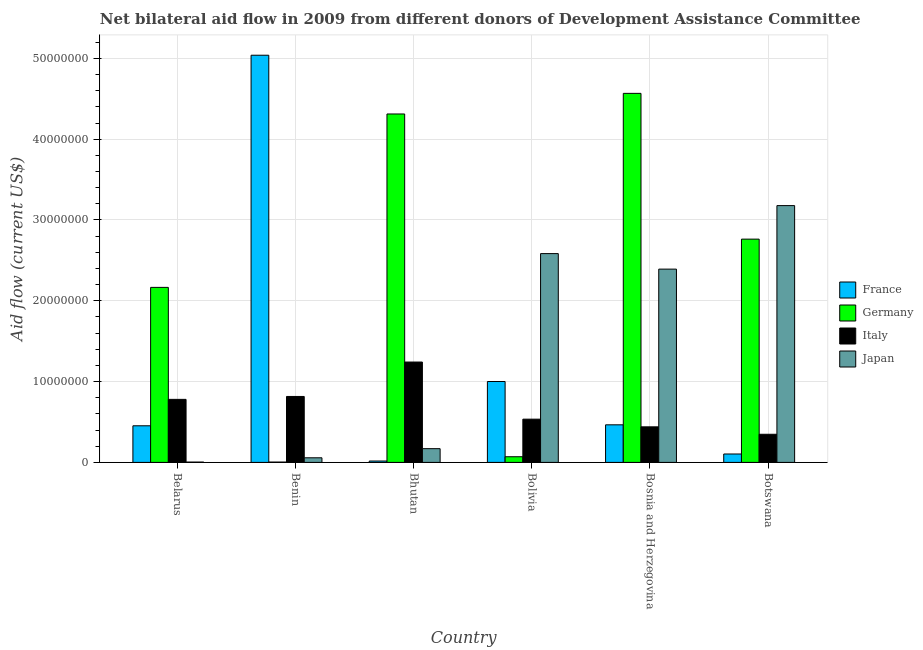Are the number of bars on each tick of the X-axis equal?
Keep it short and to the point. Yes. How many bars are there on the 4th tick from the right?
Offer a very short reply. 4. What is the label of the 6th group of bars from the left?
Offer a very short reply. Botswana. In how many cases, is the number of bars for a given country not equal to the number of legend labels?
Your response must be concise. 0. What is the amount of aid given by japan in Benin?
Give a very brief answer. 5.70e+05. Across all countries, what is the maximum amount of aid given by germany?
Offer a terse response. 4.57e+07. Across all countries, what is the minimum amount of aid given by italy?
Your answer should be very brief. 3.48e+06. In which country was the amount of aid given by italy maximum?
Your answer should be compact. Bhutan. In which country was the amount of aid given by germany minimum?
Your answer should be compact. Benin. What is the total amount of aid given by japan in the graph?
Your response must be concise. 8.38e+07. What is the difference between the amount of aid given by italy in Belarus and that in Bolivia?
Give a very brief answer. 2.45e+06. What is the difference between the amount of aid given by japan in Botswana and the amount of aid given by france in Bhutan?
Your response must be concise. 3.16e+07. What is the average amount of aid given by italy per country?
Offer a terse response. 6.94e+06. What is the difference between the amount of aid given by france and amount of aid given by germany in Bhutan?
Provide a short and direct response. -4.30e+07. In how many countries, is the amount of aid given by france greater than 8000000 US$?
Offer a very short reply. 2. What is the ratio of the amount of aid given by france in Benin to that in Bhutan?
Provide a succinct answer. 296.41. Is the amount of aid given by japan in Bhutan less than that in Bolivia?
Provide a succinct answer. Yes. What is the difference between the highest and the second highest amount of aid given by germany?
Offer a terse response. 2.55e+06. What is the difference between the highest and the lowest amount of aid given by japan?
Your response must be concise. 3.17e+07. What does the 1st bar from the right in Benin represents?
Offer a terse response. Japan. How many bars are there?
Provide a short and direct response. 24. Are all the bars in the graph horizontal?
Give a very brief answer. No. How many countries are there in the graph?
Make the answer very short. 6. Does the graph contain any zero values?
Offer a terse response. No. Does the graph contain grids?
Your response must be concise. Yes. How many legend labels are there?
Keep it short and to the point. 4. What is the title of the graph?
Provide a succinct answer. Net bilateral aid flow in 2009 from different donors of Development Assistance Committee. Does "Negligence towards children" appear as one of the legend labels in the graph?
Offer a very short reply. No. What is the label or title of the X-axis?
Your answer should be very brief. Country. What is the label or title of the Y-axis?
Provide a succinct answer. Aid flow (current US$). What is the Aid flow (current US$) of France in Belarus?
Keep it short and to the point. 4.53e+06. What is the Aid flow (current US$) in Germany in Belarus?
Your answer should be very brief. 2.17e+07. What is the Aid flow (current US$) of Italy in Belarus?
Make the answer very short. 7.80e+06. What is the Aid flow (current US$) of Japan in Belarus?
Provide a short and direct response. 4.00e+04. What is the Aid flow (current US$) in France in Benin?
Ensure brevity in your answer.  5.04e+07. What is the Aid flow (current US$) in Italy in Benin?
Provide a succinct answer. 8.16e+06. What is the Aid flow (current US$) in Japan in Benin?
Your answer should be very brief. 5.70e+05. What is the Aid flow (current US$) in France in Bhutan?
Provide a succinct answer. 1.70e+05. What is the Aid flow (current US$) of Germany in Bhutan?
Your answer should be compact. 4.31e+07. What is the Aid flow (current US$) of Italy in Bhutan?
Ensure brevity in your answer.  1.24e+07. What is the Aid flow (current US$) of Japan in Bhutan?
Your answer should be compact. 1.70e+06. What is the Aid flow (current US$) in France in Bolivia?
Offer a terse response. 1.00e+07. What is the Aid flow (current US$) in Germany in Bolivia?
Offer a very short reply. 7.00e+05. What is the Aid flow (current US$) of Italy in Bolivia?
Your answer should be very brief. 5.35e+06. What is the Aid flow (current US$) of Japan in Bolivia?
Your response must be concise. 2.58e+07. What is the Aid flow (current US$) in France in Bosnia and Herzegovina?
Give a very brief answer. 4.65e+06. What is the Aid flow (current US$) of Germany in Bosnia and Herzegovina?
Offer a terse response. 4.57e+07. What is the Aid flow (current US$) of Italy in Bosnia and Herzegovina?
Provide a succinct answer. 4.40e+06. What is the Aid flow (current US$) of Japan in Bosnia and Herzegovina?
Provide a succinct answer. 2.39e+07. What is the Aid flow (current US$) in France in Botswana?
Give a very brief answer. 1.04e+06. What is the Aid flow (current US$) in Germany in Botswana?
Offer a terse response. 2.76e+07. What is the Aid flow (current US$) of Italy in Botswana?
Give a very brief answer. 3.48e+06. What is the Aid flow (current US$) of Japan in Botswana?
Make the answer very short. 3.18e+07. Across all countries, what is the maximum Aid flow (current US$) in France?
Your answer should be compact. 5.04e+07. Across all countries, what is the maximum Aid flow (current US$) of Germany?
Ensure brevity in your answer.  4.57e+07. Across all countries, what is the maximum Aid flow (current US$) in Italy?
Offer a very short reply. 1.24e+07. Across all countries, what is the maximum Aid flow (current US$) in Japan?
Offer a very short reply. 3.18e+07. Across all countries, what is the minimum Aid flow (current US$) in France?
Ensure brevity in your answer.  1.70e+05. Across all countries, what is the minimum Aid flow (current US$) of Germany?
Your answer should be compact. 4.00e+04. Across all countries, what is the minimum Aid flow (current US$) of Italy?
Your answer should be compact. 3.48e+06. What is the total Aid flow (current US$) in France in the graph?
Provide a succinct answer. 7.08e+07. What is the total Aid flow (current US$) of Germany in the graph?
Give a very brief answer. 1.39e+08. What is the total Aid flow (current US$) of Italy in the graph?
Give a very brief answer. 4.16e+07. What is the total Aid flow (current US$) in Japan in the graph?
Give a very brief answer. 8.38e+07. What is the difference between the Aid flow (current US$) of France in Belarus and that in Benin?
Ensure brevity in your answer.  -4.59e+07. What is the difference between the Aid flow (current US$) in Germany in Belarus and that in Benin?
Your answer should be compact. 2.16e+07. What is the difference between the Aid flow (current US$) in Italy in Belarus and that in Benin?
Give a very brief answer. -3.60e+05. What is the difference between the Aid flow (current US$) of Japan in Belarus and that in Benin?
Provide a short and direct response. -5.30e+05. What is the difference between the Aid flow (current US$) in France in Belarus and that in Bhutan?
Give a very brief answer. 4.36e+06. What is the difference between the Aid flow (current US$) in Germany in Belarus and that in Bhutan?
Your answer should be compact. -2.15e+07. What is the difference between the Aid flow (current US$) of Italy in Belarus and that in Bhutan?
Provide a short and direct response. -4.62e+06. What is the difference between the Aid flow (current US$) in Japan in Belarus and that in Bhutan?
Offer a very short reply. -1.66e+06. What is the difference between the Aid flow (current US$) of France in Belarus and that in Bolivia?
Keep it short and to the point. -5.48e+06. What is the difference between the Aid flow (current US$) of Germany in Belarus and that in Bolivia?
Give a very brief answer. 2.10e+07. What is the difference between the Aid flow (current US$) in Italy in Belarus and that in Bolivia?
Your answer should be compact. 2.45e+06. What is the difference between the Aid flow (current US$) in Japan in Belarus and that in Bolivia?
Keep it short and to the point. -2.58e+07. What is the difference between the Aid flow (current US$) in France in Belarus and that in Bosnia and Herzegovina?
Give a very brief answer. -1.20e+05. What is the difference between the Aid flow (current US$) of Germany in Belarus and that in Bosnia and Herzegovina?
Give a very brief answer. -2.40e+07. What is the difference between the Aid flow (current US$) of Italy in Belarus and that in Bosnia and Herzegovina?
Offer a very short reply. 3.40e+06. What is the difference between the Aid flow (current US$) of Japan in Belarus and that in Bosnia and Herzegovina?
Your answer should be compact. -2.39e+07. What is the difference between the Aid flow (current US$) in France in Belarus and that in Botswana?
Give a very brief answer. 3.49e+06. What is the difference between the Aid flow (current US$) of Germany in Belarus and that in Botswana?
Offer a terse response. -5.97e+06. What is the difference between the Aid flow (current US$) of Italy in Belarus and that in Botswana?
Your answer should be very brief. 4.32e+06. What is the difference between the Aid flow (current US$) of Japan in Belarus and that in Botswana?
Provide a short and direct response. -3.17e+07. What is the difference between the Aid flow (current US$) of France in Benin and that in Bhutan?
Your answer should be compact. 5.02e+07. What is the difference between the Aid flow (current US$) in Germany in Benin and that in Bhutan?
Your response must be concise. -4.31e+07. What is the difference between the Aid flow (current US$) of Italy in Benin and that in Bhutan?
Provide a short and direct response. -4.26e+06. What is the difference between the Aid flow (current US$) of Japan in Benin and that in Bhutan?
Ensure brevity in your answer.  -1.13e+06. What is the difference between the Aid flow (current US$) in France in Benin and that in Bolivia?
Your answer should be compact. 4.04e+07. What is the difference between the Aid flow (current US$) of Germany in Benin and that in Bolivia?
Make the answer very short. -6.60e+05. What is the difference between the Aid flow (current US$) of Italy in Benin and that in Bolivia?
Keep it short and to the point. 2.81e+06. What is the difference between the Aid flow (current US$) in Japan in Benin and that in Bolivia?
Provide a succinct answer. -2.53e+07. What is the difference between the Aid flow (current US$) in France in Benin and that in Bosnia and Herzegovina?
Provide a succinct answer. 4.57e+07. What is the difference between the Aid flow (current US$) of Germany in Benin and that in Bosnia and Herzegovina?
Your answer should be very brief. -4.56e+07. What is the difference between the Aid flow (current US$) in Italy in Benin and that in Bosnia and Herzegovina?
Your response must be concise. 3.76e+06. What is the difference between the Aid flow (current US$) of Japan in Benin and that in Bosnia and Herzegovina?
Your answer should be very brief. -2.34e+07. What is the difference between the Aid flow (current US$) in France in Benin and that in Botswana?
Provide a short and direct response. 4.94e+07. What is the difference between the Aid flow (current US$) in Germany in Benin and that in Botswana?
Give a very brief answer. -2.76e+07. What is the difference between the Aid flow (current US$) of Italy in Benin and that in Botswana?
Keep it short and to the point. 4.68e+06. What is the difference between the Aid flow (current US$) of Japan in Benin and that in Botswana?
Ensure brevity in your answer.  -3.12e+07. What is the difference between the Aid flow (current US$) in France in Bhutan and that in Bolivia?
Your response must be concise. -9.84e+06. What is the difference between the Aid flow (current US$) in Germany in Bhutan and that in Bolivia?
Ensure brevity in your answer.  4.24e+07. What is the difference between the Aid flow (current US$) in Italy in Bhutan and that in Bolivia?
Offer a very short reply. 7.07e+06. What is the difference between the Aid flow (current US$) in Japan in Bhutan and that in Bolivia?
Provide a succinct answer. -2.41e+07. What is the difference between the Aid flow (current US$) of France in Bhutan and that in Bosnia and Herzegovina?
Provide a succinct answer. -4.48e+06. What is the difference between the Aid flow (current US$) of Germany in Bhutan and that in Bosnia and Herzegovina?
Give a very brief answer. -2.55e+06. What is the difference between the Aid flow (current US$) in Italy in Bhutan and that in Bosnia and Herzegovina?
Offer a very short reply. 8.02e+06. What is the difference between the Aid flow (current US$) in Japan in Bhutan and that in Bosnia and Herzegovina?
Make the answer very short. -2.22e+07. What is the difference between the Aid flow (current US$) in France in Bhutan and that in Botswana?
Offer a very short reply. -8.70e+05. What is the difference between the Aid flow (current US$) of Germany in Bhutan and that in Botswana?
Your answer should be very brief. 1.55e+07. What is the difference between the Aid flow (current US$) in Italy in Bhutan and that in Botswana?
Your response must be concise. 8.94e+06. What is the difference between the Aid flow (current US$) of Japan in Bhutan and that in Botswana?
Your answer should be compact. -3.01e+07. What is the difference between the Aid flow (current US$) in France in Bolivia and that in Bosnia and Herzegovina?
Your answer should be compact. 5.36e+06. What is the difference between the Aid flow (current US$) of Germany in Bolivia and that in Bosnia and Herzegovina?
Provide a succinct answer. -4.50e+07. What is the difference between the Aid flow (current US$) in Italy in Bolivia and that in Bosnia and Herzegovina?
Keep it short and to the point. 9.50e+05. What is the difference between the Aid flow (current US$) in Japan in Bolivia and that in Bosnia and Herzegovina?
Your response must be concise. 1.92e+06. What is the difference between the Aid flow (current US$) in France in Bolivia and that in Botswana?
Ensure brevity in your answer.  8.97e+06. What is the difference between the Aid flow (current US$) in Germany in Bolivia and that in Botswana?
Provide a succinct answer. -2.69e+07. What is the difference between the Aid flow (current US$) of Italy in Bolivia and that in Botswana?
Ensure brevity in your answer.  1.87e+06. What is the difference between the Aid flow (current US$) of Japan in Bolivia and that in Botswana?
Keep it short and to the point. -5.94e+06. What is the difference between the Aid flow (current US$) of France in Bosnia and Herzegovina and that in Botswana?
Your answer should be compact. 3.61e+06. What is the difference between the Aid flow (current US$) of Germany in Bosnia and Herzegovina and that in Botswana?
Offer a very short reply. 1.80e+07. What is the difference between the Aid flow (current US$) of Italy in Bosnia and Herzegovina and that in Botswana?
Make the answer very short. 9.20e+05. What is the difference between the Aid flow (current US$) of Japan in Bosnia and Herzegovina and that in Botswana?
Give a very brief answer. -7.86e+06. What is the difference between the Aid flow (current US$) of France in Belarus and the Aid flow (current US$) of Germany in Benin?
Give a very brief answer. 4.49e+06. What is the difference between the Aid flow (current US$) of France in Belarus and the Aid flow (current US$) of Italy in Benin?
Your response must be concise. -3.63e+06. What is the difference between the Aid flow (current US$) of France in Belarus and the Aid flow (current US$) of Japan in Benin?
Provide a short and direct response. 3.96e+06. What is the difference between the Aid flow (current US$) in Germany in Belarus and the Aid flow (current US$) in Italy in Benin?
Provide a succinct answer. 1.35e+07. What is the difference between the Aid flow (current US$) in Germany in Belarus and the Aid flow (current US$) in Japan in Benin?
Make the answer very short. 2.11e+07. What is the difference between the Aid flow (current US$) of Italy in Belarus and the Aid flow (current US$) of Japan in Benin?
Offer a terse response. 7.23e+06. What is the difference between the Aid flow (current US$) of France in Belarus and the Aid flow (current US$) of Germany in Bhutan?
Give a very brief answer. -3.86e+07. What is the difference between the Aid flow (current US$) of France in Belarus and the Aid flow (current US$) of Italy in Bhutan?
Your response must be concise. -7.89e+06. What is the difference between the Aid flow (current US$) in France in Belarus and the Aid flow (current US$) in Japan in Bhutan?
Make the answer very short. 2.83e+06. What is the difference between the Aid flow (current US$) of Germany in Belarus and the Aid flow (current US$) of Italy in Bhutan?
Offer a very short reply. 9.24e+06. What is the difference between the Aid flow (current US$) of Germany in Belarus and the Aid flow (current US$) of Japan in Bhutan?
Your answer should be very brief. 2.00e+07. What is the difference between the Aid flow (current US$) of Italy in Belarus and the Aid flow (current US$) of Japan in Bhutan?
Your response must be concise. 6.10e+06. What is the difference between the Aid flow (current US$) in France in Belarus and the Aid flow (current US$) in Germany in Bolivia?
Offer a terse response. 3.83e+06. What is the difference between the Aid flow (current US$) in France in Belarus and the Aid flow (current US$) in Italy in Bolivia?
Provide a short and direct response. -8.20e+05. What is the difference between the Aid flow (current US$) of France in Belarus and the Aid flow (current US$) of Japan in Bolivia?
Your answer should be very brief. -2.13e+07. What is the difference between the Aid flow (current US$) in Germany in Belarus and the Aid flow (current US$) in Italy in Bolivia?
Give a very brief answer. 1.63e+07. What is the difference between the Aid flow (current US$) of Germany in Belarus and the Aid flow (current US$) of Japan in Bolivia?
Make the answer very short. -4.18e+06. What is the difference between the Aid flow (current US$) of Italy in Belarus and the Aid flow (current US$) of Japan in Bolivia?
Ensure brevity in your answer.  -1.80e+07. What is the difference between the Aid flow (current US$) of France in Belarus and the Aid flow (current US$) of Germany in Bosnia and Herzegovina?
Provide a short and direct response. -4.11e+07. What is the difference between the Aid flow (current US$) of France in Belarus and the Aid flow (current US$) of Japan in Bosnia and Herzegovina?
Give a very brief answer. -1.94e+07. What is the difference between the Aid flow (current US$) of Germany in Belarus and the Aid flow (current US$) of Italy in Bosnia and Herzegovina?
Ensure brevity in your answer.  1.73e+07. What is the difference between the Aid flow (current US$) in Germany in Belarus and the Aid flow (current US$) in Japan in Bosnia and Herzegovina?
Give a very brief answer. -2.26e+06. What is the difference between the Aid flow (current US$) of Italy in Belarus and the Aid flow (current US$) of Japan in Bosnia and Herzegovina?
Keep it short and to the point. -1.61e+07. What is the difference between the Aid flow (current US$) of France in Belarus and the Aid flow (current US$) of Germany in Botswana?
Offer a terse response. -2.31e+07. What is the difference between the Aid flow (current US$) in France in Belarus and the Aid flow (current US$) in Italy in Botswana?
Provide a succinct answer. 1.05e+06. What is the difference between the Aid flow (current US$) of France in Belarus and the Aid flow (current US$) of Japan in Botswana?
Your answer should be very brief. -2.72e+07. What is the difference between the Aid flow (current US$) in Germany in Belarus and the Aid flow (current US$) in Italy in Botswana?
Offer a terse response. 1.82e+07. What is the difference between the Aid flow (current US$) in Germany in Belarus and the Aid flow (current US$) in Japan in Botswana?
Make the answer very short. -1.01e+07. What is the difference between the Aid flow (current US$) of Italy in Belarus and the Aid flow (current US$) of Japan in Botswana?
Keep it short and to the point. -2.40e+07. What is the difference between the Aid flow (current US$) of France in Benin and the Aid flow (current US$) of Germany in Bhutan?
Provide a succinct answer. 7.27e+06. What is the difference between the Aid flow (current US$) of France in Benin and the Aid flow (current US$) of Italy in Bhutan?
Keep it short and to the point. 3.80e+07. What is the difference between the Aid flow (current US$) in France in Benin and the Aid flow (current US$) in Japan in Bhutan?
Ensure brevity in your answer.  4.87e+07. What is the difference between the Aid flow (current US$) in Germany in Benin and the Aid flow (current US$) in Italy in Bhutan?
Provide a succinct answer. -1.24e+07. What is the difference between the Aid flow (current US$) in Germany in Benin and the Aid flow (current US$) in Japan in Bhutan?
Ensure brevity in your answer.  -1.66e+06. What is the difference between the Aid flow (current US$) of Italy in Benin and the Aid flow (current US$) of Japan in Bhutan?
Offer a very short reply. 6.46e+06. What is the difference between the Aid flow (current US$) of France in Benin and the Aid flow (current US$) of Germany in Bolivia?
Provide a succinct answer. 4.97e+07. What is the difference between the Aid flow (current US$) in France in Benin and the Aid flow (current US$) in Italy in Bolivia?
Give a very brief answer. 4.50e+07. What is the difference between the Aid flow (current US$) of France in Benin and the Aid flow (current US$) of Japan in Bolivia?
Keep it short and to the point. 2.46e+07. What is the difference between the Aid flow (current US$) of Germany in Benin and the Aid flow (current US$) of Italy in Bolivia?
Make the answer very short. -5.31e+06. What is the difference between the Aid flow (current US$) of Germany in Benin and the Aid flow (current US$) of Japan in Bolivia?
Offer a very short reply. -2.58e+07. What is the difference between the Aid flow (current US$) of Italy in Benin and the Aid flow (current US$) of Japan in Bolivia?
Your answer should be compact. -1.77e+07. What is the difference between the Aid flow (current US$) of France in Benin and the Aid flow (current US$) of Germany in Bosnia and Herzegovina?
Your answer should be very brief. 4.72e+06. What is the difference between the Aid flow (current US$) in France in Benin and the Aid flow (current US$) in Italy in Bosnia and Herzegovina?
Your answer should be very brief. 4.60e+07. What is the difference between the Aid flow (current US$) in France in Benin and the Aid flow (current US$) in Japan in Bosnia and Herzegovina?
Offer a very short reply. 2.65e+07. What is the difference between the Aid flow (current US$) in Germany in Benin and the Aid flow (current US$) in Italy in Bosnia and Herzegovina?
Keep it short and to the point. -4.36e+06. What is the difference between the Aid flow (current US$) of Germany in Benin and the Aid flow (current US$) of Japan in Bosnia and Herzegovina?
Your answer should be very brief. -2.39e+07. What is the difference between the Aid flow (current US$) in Italy in Benin and the Aid flow (current US$) in Japan in Bosnia and Herzegovina?
Your response must be concise. -1.58e+07. What is the difference between the Aid flow (current US$) of France in Benin and the Aid flow (current US$) of Germany in Botswana?
Provide a succinct answer. 2.28e+07. What is the difference between the Aid flow (current US$) in France in Benin and the Aid flow (current US$) in Italy in Botswana?
Provide a short and direct response. 4.69e+07. What is the difference between the Aid flow (current US$) of France in Benin and the Aid flow (current US$) of Japan in Botswana?
Give a very brief answer. 1.86e+07. What is the difference between the Aid flow (current US$) in Germany in Benin and the Aid flow (current US$) in Italy in Botswana?
Your answer should be compact. -3.44e+06. What is the difference between the Aid flow (current US$) of Germany in Benin and the Aid flow (current US$) of Japan in Botswana?
Ensure brevity in your answer.  -3.17e+07. What is the difference between the Aid flow (current US$) of Italy in Benin and the Aid flow (current US$) of Japan in Botswana?
Keep it short and to the point. -2.36e+07. What is the difference between the Aid flow (current US$) in France in Bhutan and the Aid flow (current US$) in Germany in Bolivia?
Your answer should be compact. -5.30e+05. What is the difference between the Aid flow (current US$) in France in Bhutan and the Aid flow (current US$) in Italy in Bolivia?
Keep it short and to the point. -5.18e+06. What is the difference between the Aid flow (current US$) in France in Bhutan and the Aid flow (current US$) in Japan in Bolivia?
Keep it short and to the point. -2.57e+07. What is the difference between the Aid flow (current US$) of Germany in Bhutan and the Aid flow (current US$) of Italy in Bolivia?
Provide a short and direct response. 3.78e+07. What is the difference between the Aid flow (current US$) in Germany in Bhutan and the Aid flow (current US$) in Japan in Bolivia?
Keep it short and to the point. 1.73e+07. What is the difference between the Aid flow (current US$) in Italy in Bhutan and the Aid flow (current US$) in Japan in Bolivia?
Your answer should be compact. -1.34e+07. What is the difference between the Aid flow (current US$) in France in Bhutan and the Aid flow (current US$) in Germany in Bosnia and Herzegovina?
Offer a very short reply. -4.55e+07. What is the difference between the Aid flow (current US$) in France in Bhutan and the Aid flow (current US$) in Italy in Bosnia and Herzegovina?
Ensure brevity in your answer.  -4.23e+06. What is the difference between the Aid flow (current US$) in France in Bhutan and the Aid flow (current US$) in Japan in Bosnia and Herzegovina?
Provide a short and direct response. -2.38e+07. What is the difference between the Aid flow (current US$) in Germany in Bhutan and the Aid flow (current US$) in Italy in Bosnia and Herzegovina?
Your answer should be compact. 3.87e+07. What is the difference between the Aid flow (current US$) in Germany in Bhutan and the Aid flow (current US$) in Japan in Bosnia and Herzegovina?
Ensure brevity in your answer.  1.92e+07. What is the difference between the Aid flow (current US$) in Italy in Bhutan and the Aid flow (current US$) in Japan in Bosnia and Herzegovina?
Make the answer very short. -1.15e+07. What is the difference between the Aid flow (current US$) of France in Bhutan and the Aid flow (current US$) of Germany in Botswana?
Offer a terse response. -2.75e+07. What is the difference between the Aid flow (current US$) in France in Bhutan and the Aid flow (current US$) in Italy in Botswana?
Provide a short and direct response. -3.31e+06. What is the difference between the Aid flow (current US$) of France in Bhutan and the Aid flow (current US$) of Japan in Botswana?
Keep it short and to the point. -3.16e+07. What is the difference between the Aid flow (current US$) in Germany in Bhutan and the Aid flow (current US$) in Italy in Botswana?
Provide a succinct answer. 3.96e+07. What is the difference between the Aid flow (current US$) of Germany in Bhutan and the Aid flow (current US$) of Japan in Botswana?
Offer a very short reply. 1.13e+07. What is the difference between the Aid flow (current US$) of Italy in Bhutan and the Aid flow (current US$) of Japan in Botswana?
Your answer should be compact. -1.94e+07. What is the difference between the Aid flow (current US$) of France in Bolivia and the Aid flow (current US$) of Germany in Bosnia and Herzegovina?
Give a very brief answer. -3.57e+07. What is the difference between the Aid flow (current US$) in France in Bolivia and the Aid flow (current US$) in Italy in Bosnia and Herzegovina?
Your response must be concise. 5.61e+06. What is the difference between the Aid flow (current US$) in France in Bolivia and the Aid flow (current US$) in Japan in Bosnia and Herzegovina?
Give a very brief answer. -1.39e+07. What is the difference between the Aid flow (current US$) of Germany in Bolivia and the Aid flow (current US$) of Italy in Bosnia and Herzegovina?
Your response must be concise. -3.70e+06. What is the difference between the Aid flow (current US$) in Germany in Bolivia and the Aid flow (current US$) in Japan in Bosnia and Herzegovina?
Keep it short and to the point. -2.32e+07. What is the difference between the Aid flow (current US$) in Italy in Bolivia and the Aid flow (current US$) in Japan in Bosnia and Herzegovina?
Your answer should be compact. -1.86e+07. What is the difference between the Aid flow (current US$) in France in Bolivia and the Aid flow (current US$) in Germany in Botswana?
Provide a succinct answer. -1.76e+07. What is the difference between the Aid flow (current US$) in France in Bolivia and the Aid flow (current US$) in Italy in Botswana?
Your answer should be compact. 6.53e+06. What is the difference between the Aid flow (current US$) in France in Bolivia and the Aid flow (current US$) in Japan in Botswana?
Provide a short and direct response. -2.18e+07. What is the difference between the Aid flow (current US$) of Germany in Bolivia and the Aid flow (current US$) of Italy in Botswana?
Make the answer very short. -2.78e+06. What is the difference between the Aid flow (current US$) in Germany in Bolivia and the Aid flow (current US$) in Japan in Botswana?
Ensure brevity in your answer.  -3.11e+07. What is the difference between the Aid flow (current US$) of Italy in Bolivia and the Aid flow (current US$) of Japan in Botswana?
Make the answer very short. -2.64e+07. What is the difference between the Aid flow (current US$) of France in Bosnia and Herzegovina and the Aid flow (current US$) of Germany in Botswana?
Your answer should be compact. -2.30e+07. What is the difference between the Aid flow (current US$) in France in Bosnia and Herzegovina and the Aid flow (current US$) in Italy in Botswana?
Give a very brief answer. 1.17e+06. What is the difference between the Aid flow (current US$) in France in Bosnia and Herzegovina and the Aid flow (current US$) in Japan in Botswana?
Make the answer very short. -2.71e+07. What is the difference between the Aid flow (current US$) of Germany in Bosnia and Herzegovina and the Aid flow (current US$) of Italy in Botswana?
Your answer should be very brief. 4.22e+07. What is the difference between the Aid flow (current US$) in Germany in Bosnia and Herzegovina and the Aid flow (current US$) in Japan in Botswana?
Keep it short and to the point. 1.39e+07. What is the difference between the Aid flow (current US$) of Italy in Bosnia and Herzegovina and the Aid flow (current US$) of Japan in Botswana?
Make the answer very short. -2.74e+07. What is the average Aid flow (current US$) in France per country?
Provide a succinct answer. 1.18e+07. What is the average Aid flow (current US$) in Germany per country?
Your answer should be compact. 2.31e+07. What is the average Aid flow (current US$) in Italy per country?
Ensure brevity in your answer.  6.94e+06. What is the average Aid flow (current US$) of Japan per country?
Ensure brevity in your answer.  1.40e+07. What is the difference between the Aid flow (current US$) in France and Aid flow (current US$) in Germany in Belarus?
Give a very brief answer. -1.71e+07. What is the difference between the Aid flow (current US$) in France and Aid flow (current US$) in Italy in Belarus?
Your answer should be compact. -3.27e+06. What is the difference between the Aid flow (current US$) of France and Aid flow (current US$) of Japan in Belarus?
Your answer should be compact. 4.49e+06. What is the difference between the Aid flow (current US$) of Germany and Aid flow (current US$) of Italy in Belarus?
Make the answer very short. 1.39e+07. What is the difference between the Aid flow (current US$) of Germany and Aid flow (current US$) of Japan in Belarus?
Keep it short and to the point. 2.16e+07. What is the difference between the Aid flow (current US$) in Italy and Aid flow (current US$) in Japan in Belarus?
Keep it short and to the point. 7.76e+06. What is the difference between the Aid flow (current US$) in France and Aid flow (current US$) in Germany in Benin?
Offer a very short reply. 5.04e+07. What is the difference between the Aid flow (current US$) of France and Aid flow (current US$) of Italy in Benin?
Your answer should be compact. 4.22e+07. What is the difference between the Aid flow (current US$) in France and Aid flow (current US$) in Japan in Benin?
Offer a very short reply. 4.98e+07. What is the difference between the Aid flow (current US$) in Germany and Aid flow (current US$) in Italy in Benin?
Your answer should be compact. -8.12e+06. What is the difference between the Aid flow (current US$) of Germany and Aid flow (current US$) of Japan in Benin?
Your answer should be compact. -5.30e+05. What is the difference between the Aid flow (current US$) in Italy and Aid flow (current US$) in Japan in Benin?
Provide a succinct answer. 7.59e+06. What is the difference between the Aid flow (current US$) in France and Aid flow (current US$) in Germany in Bhutan?
Give a very brief answer. -4.30e+07. What is the difference between the Aid flow (current US$) of France and Aid flow (current US$) of Italy in Bhutan?
Your response must be concise. -1.22e+07. What is the difference between the Aid flow (current US$) in France and Aid flow (current US$) in Japan in Bhutan?
Provide a succinct answer. -1.53e+06. What is the difference between the Aid flow (current US$) in Germany and Aid flow (current US$) in Italy in Bhutan?
Provide a short and direct response. 3.07e+07. What is the difference between the Aid flow (current US$) of Germany and Aid flow (current US$) of Japan in Bhutan?
Your response must be concise. 4.14e+07. What is the difference between the Aid flow (current US$) in Italy and Aid flow (current US$) in Japan in Bhutan?
Offer a very short reply. 1.07e+07. What is the difference between the Aid flow (current US$) in France and Aid flow (current US$) in Germany in Bolivia?
Your answer should be compact. 9.31e+06. What is the difference between the Aid flow (current US$) of France and Aid flow (current US$) of Italy in Bolivia?
Offer a terse response. 4.66e+06. What is the difference between the Aid flow (current US$) of France and Aid flow (current US$) of Japan in Bolivia?
Your answer should be compact. -1.58e+07. What is the difference between the Aid flow (current US$) of Germany and Aid flow (current US$) of Italy in Bolivia?
Give a very brief answer. -4.65e+06. What is the difference between the Aid flow (current US$) in Germany and Aid flow (current US$) in Japan in Bolivia?
Offer a terse response. -2.51e+07. What is the difference between the Aid flow (current US$) of Italy and Aid flow (current US$) of Japan in Bolivia?
Your answer should be very brief. -2.05e+07. What is the difference between the Aid flow (current US$) in France and Aid flow (current US$) in Germany in Bosnia and Herzegovina?
Offer a very short reply. -4.10e+07. What is the difference between the Aid flow (current US$) in France and Aid flow (current US$) in Japan in Bosnia and Herzegovina?
Keep it short and to the point. -1.93e+07. What is the difference between the Aid flow (current US$) of Germany and Aid flow (current US$) of Italy in Bosnia and Herzegovina?
Offer a terse response. 4.13e+07. What is the difference between the Aid flow (current US$) in Germany and Aid flow (current US$) in Japan in Bosnia and Herzegovina?
Give a very brief answer. 2.18e+07. What is the difference between the Aid flow (current US$) in Italy and Aid flow (current US$) in Japan in Bosnia and Herzegovina?
Your answer should be compact. -1.95e+07. What is the difference between the Aid flow (current US$) of France and Aid flow (current US$) of Germany in Botswana?
Your answer should be compact. -2.66e+07. What is the difference between the Aid flow (current US$) of France and Aid flow (current US$) of Italy in Botswana?
Offer a terse response. -2.44e+06. What is the difference between the Aid flow (current US$) of France and Aid flow (current US$) of Japan in Botswana?
Give a very brief answer. -3.07e+07. What is the difference between the Aid flow (current US$) in Germany and Aid flow (current US$) in Italy in Botswana?
Make the answer very short. 2.42e+07. What is the difference between the Aid flow (current US$) of Germany and Aid flow (current US$) of Japan in Botswana?
Ensure brevity in your answer.  -4.15e+06. What is the difference between the Aid flow (current US$) in Italy and Aid flow (current US$) in Japan in Botswana?
Give a very brief answer. -2.83e+07. What is the ratio of the Aid flow (current US$) of France in Belarus to that in Benin?
Keep it short and to the point. 0.09. What is the ratio of the Aid flow (current US$) of Germany in Belarus to that in Benin?
Offer a terse response. 541.5. What is the ratio of the Aid flow (current US$) of Italy in Belarus to that in Benin?
Keep it short and to the point. 0.96. What is the ratio of the Aid flow (current US$) in Japan in Belarus to that in Benin?
Your answer should be very brief. 0.07. What is the ratio of the Aid flow (current US$) of France in Belarus to that in Bhutan?
Keep it short and to the point. 26.65. What is the ratio of the Aid flow (current US$) of Germany in Belarus to that in Bhutan?
Provide a short and direct response. 0.5. What is the ratio of the Aid flow (current US$) of Italy in Belarus to that in Bhutan?
Offer a very short reply. 0.63. What is the ratio of the Aid flow (current US$) in Japan in Belarus to that in Bhutan?
Offer a terse response. 0.02. What is the ratio of the Aid flow (current US$) in France in Belarus to that in Bolivia?
Your response must be concise. 0.45. What is the ratio of the Aid flow (current US$) of Germany in Belarus to that in Bolivia?
Keep it short and to the point. 30.94. What is the ratio of the Aid flow (current US$) of Italy in Belarus to that in Bolivia?
Your answer should be very brief. 1.46. What is the ratio of the Aid flow (current US$) of Japan in Belarus to that in Bolivia?
Make the answer very short. 0. What is the ratio of the Aid flow (current US$) of France in Belarus to that in Bosnia and Herzegovina?
Provide a succinct answer. 0.97. What is the ratio of the Aid flow (current US$) in Germany in Belarus to that in Bosnia and Herzegovina?
Your answer should be compact. 0.47. What is the ratio of the Aid flow (current US$) in Italy in Belarus to that in Bosnia and Herzegovina?
Provide a short and direct response. 1.77. What is the ratio of the Aid flow (current US$) of Japan in Belarus to that in Bosnia and Herzegovina?
Keep it short and to the point. 0. What is the ratio of the Aid flow (current US$) of France in Belarus to that in Botswana?
Your answer should be very brief. 4.36. What is the ratio of the Aid flow (current US$) of Germany in Belarus to that in Botswana?
Your answer should be compact. 0.78. What is the ratio of the Aid flow (current US$) of Italy in Belarus to that in Botswana?
Offer a terse response. 2.24. What is the ratio of the Aid flow (current US$) of Japan in Belarus to that in Botswana?
Provide a short and direct response. 0. What is the ratio of the Aid flow (current US$) of France in Benin to that in Bhutan?
Your answer should be very brief. 296.41. What is the ratio of the Aid flow (current US$) in Germany in Benin to that in Bhutan?
Keep it short and to the point. 0. What is the ratio of the Aid flow (current US$) of Italy in Benin to that in Bhutan?
Provide a short and direct response. 0.66. What is the ratio of the Aid flow (current US$) in Japan in Benin to that in Bhutan?
Offer a terse response. 0.34. What is the ratio of the Aid flow (current US$) of France in Benin to that in Bolivia?
Your response must be concise. 5.03. What is the ratio of the Aid flow (current US$) in Germany in Benin to that in Bolivia?
Offer a very short reply. 0.06. What is the ratio of the Aid flow (current US$) in Italy in Benin to that in Bolivia?
Provide a short and direct response. 1.53. What is the ratio of the Aid flow (current US$) of Japan in Benin to that in Bolivia?
Make the answer very short. 0.02. What is the ratio of the Aid flow (current US$) of France in Benin to that in Bosnia and Herzegovina?
Offer a terse response. 10.84. What is the ratio of the Aid flow (current US$) of Germany in Benin to that in Bosnia and Herzegovina?
Your answer should be compact. 0. What is the ratio of the Aid flow (current US$) of Italy in Benin to that in Bosnia and Herzegovina?
Give a very brief answer. 1.85. What is the ratio of the Aid flow (current US$) of Japan in Benin to that in Bosnia and Herzegovina?
Ensure brevity in your answer.  0.02. What is the ratio of the Aid flow (current US$) in France in Benin to that in Botswana?
Your answer should be compact. 48.45. What is the ratio of the Aid flow (current US$) of Germany in Benin to that in Botswana?
Ensure brevity in your answer.  0. What is the ratio of the Aid flow (current US$) of Italy in Benin to that in Botswana?
Offer a terse response. 2.34. What is the ratio of the Aid flow (current US$) in Japan in Benin to that in Botswana?
Offer a terse response. 0.02. What is the ratio of the Aid flow (current US$) of France in Bhutan to that in Bolivia?
Your answer should be very brief. 0.02. What is the ratio of the Aid flow (current US$) of Germany in Bhutan to that in Bolivia?
Keep it short and to the point. 61.6. What is the ratio of the Aid flow (current US$) in Italy in Bhutan to that in Bolivia?
Make the answer very short. 2.32. What is the ratio of the Aid flow (current US$) of Japan in Bhutan to that in Bolivia?
Offer a terse response. 0.07. What is the ratio of the Aid flow (current US$) in France in Bhutan to that in Bosnia and Herzegovina?
Your answer should be compact. 0.04. What is the ratio of the Aid flow (current US$) in Germany in Bhutan to that in Bosnia and Herzegovina?
Provide a short and direct response. 0.94. What is the ratio of the Aid flow (current US$) in Italy in Bhutan to that in Bosnia and Herzegovina?
Give a very brief answer. 2.82. What is the ratio of the Aid flow (current US$) of Japan in Bhutan to that in Bosnia and Herzegovina?
Offer a terse response. 0.07. What is the ratio of the Aid flow (current US$) of France in Bhutan to that in Botswana?
Offer a terse response. 0.16. What is the ratio of the Aid flow (current US$) in Germany in Bhutan to that in Botswana?
Your response must be concise. 1.56. What is the ratio of the Aid flow (current US$) of Italy in Bhutan to that in Botswana?
Give a very brief answer. 3.57. What is the ratio of the Aid flow (current US$) of Japan in Bhutan to that in Botswana?
Your answer should be compact. 0.05. What is the ratio of the Aid flow (current US$) in France in Bolivia to that in Bosnia and Herzegovina?
Your response must be concise. 2.15. What is the ratio of the Aid flow (current US$) in Germany in Bolivia to that in Bosnia and Herzegovina?
Your response must be concise. 0.02. What is the ratio of the Aid flow (current US$) in Italy in Bolivia to that in Bosnia and Herzegovina?
Ensure brevity in your answer.  1.22. What is the ratio of the Aid flow (current US$) of Japan in Bolivia to that in Bosnia and Herzegovina?
Offer a terse response. 1.08. What is the ratio of the Aid flow (current US$) in France in Bolivia to that in Botswana?
Provide a short and direct response. 9.62. What is the ratio of the Aid flow (current US$) in Germany in Bolivia to that in Botswana?
Provide a short and direct response. 0.03. What is the ratio of the Aid flow (current US$) in Italy in Bolivia to that in Botswana?
Provide a short and direct response. 1.54. What is the ratio of the Aid flow (current US$) of Japan in Bolivia to that in Botswana?
Your answer should be compact. 0.81. What is the ratio of the Aid flow (current US$) of France in Bosnia and Herzegovina to that in Botswana?
Keep it short and to the point. 4.47. What is the ratio of the Aid flow (current US$) in Germany in Bosnia and Herzegovina to that in Botswana?
Ensure brevity in your answer.  1.65. What is the ratio of the Aid flow (current US$) of Italy in Bosnia and Herzegovina to that in Botswana?
Provide a short and direct response. 1.26. What is the ratio of the Aid flow (current US$) in Japan in Bosnia and Herzegovina to that in Botswana?
Give a very brief answer. 0.75. What is the difference between the highest and the second highest Aid flow (current US$) of France?
Your response must be concise. 4.04e+07. What is the difference between the highest and the second highest Aid flow (current US$) in Germany?
Provide a short and direct response. 2.55e+06. What is the difference between the highest and the second highest Aid flow (current US$) in Italy?
Provide a succinct answer. 4.26e+06. What is the difference between the highest and the second highest Aid flow (current US$) of Japan?
Offer a terse response. 5.94e+06. What is the difference between the highest and the lowest Aid flow (current US$) in France?
Make the answer very short. 5.02e+07. What is the difference between the highest and the lowest Aid flow (current US$) in Germany?
Provide a short and direct response. 4.56e+07. What is the difference between the highest and the lowest Aid flow (current US$) in Italy?
Your answer should be very brief. 8.94e+06. What is the difference between the highest and the lowest Aid flow (current US$) of Japan?
Ensure brevity in your answer.  3.17e+07. 